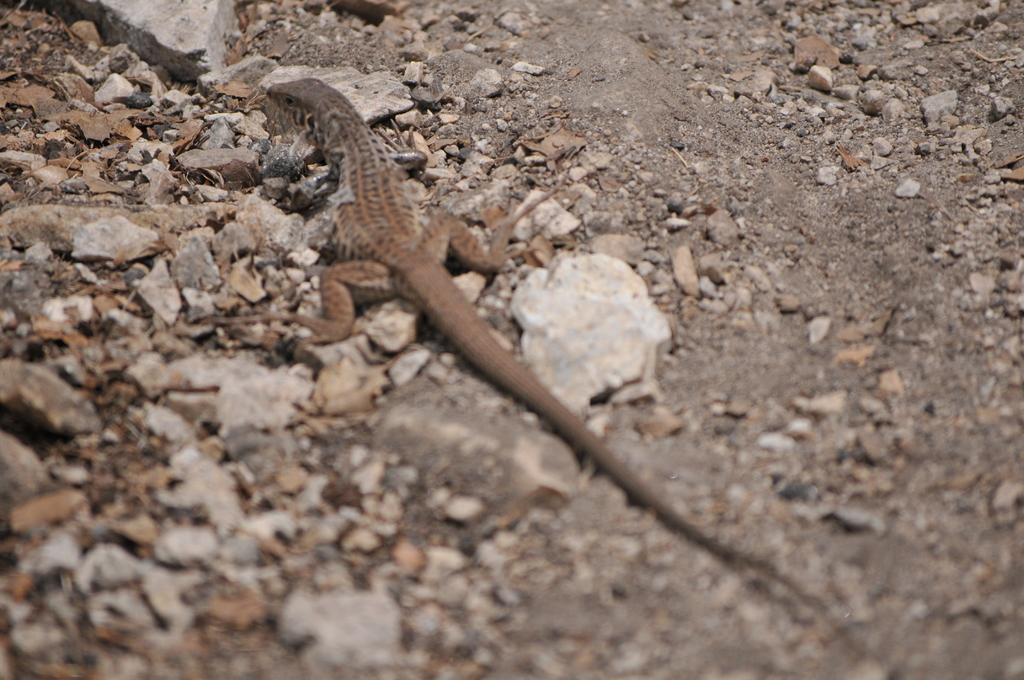What type of animal can be seen in the image? There is a lizard in the image. Where is the lizard located in the image? The lizard is sitting on the ground. What type of vegetation or plant material is visible in the image? Dry leaves are visible in the image. What type of inorganic material is present in the image? Stones are present in the image. What type of coat is the lizard wearing in the image? The lizard is not wearing a coat in the image, as reptiles do not wear clothing. 